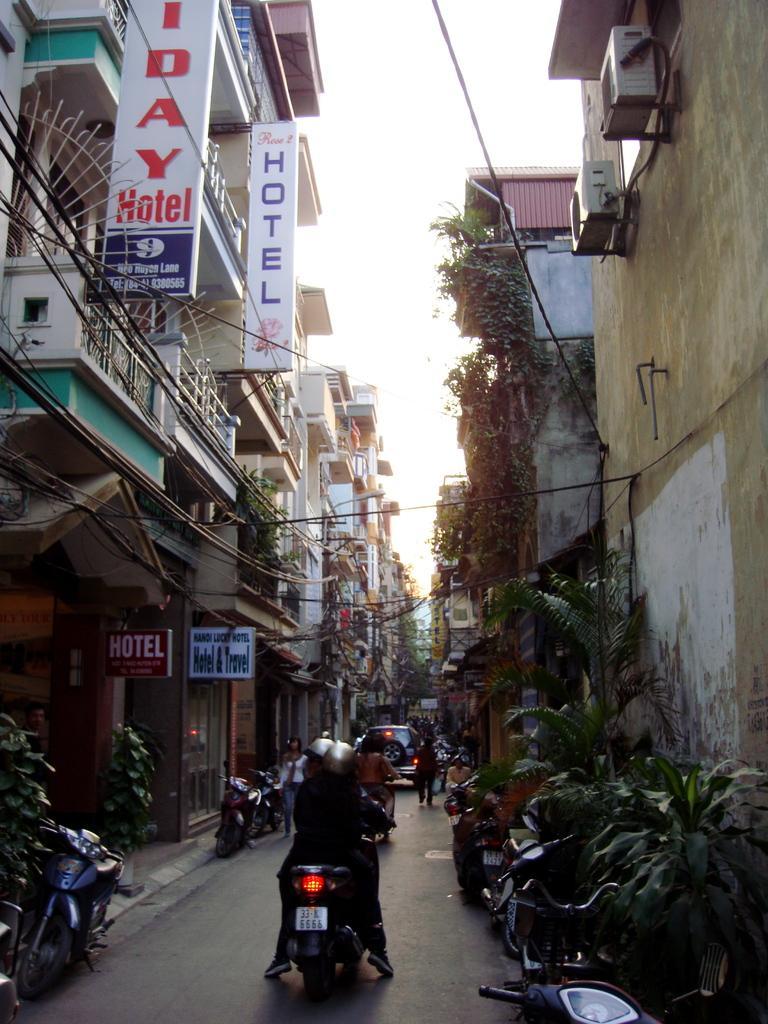How would you summarize this image in a sentence or two? In this image, we can see buildings, walls, railings, plants, wires, boards, vehicles and people. At the bottom of the image, we can see people riding vehicle through the walkway. In the background, there is the sky. 